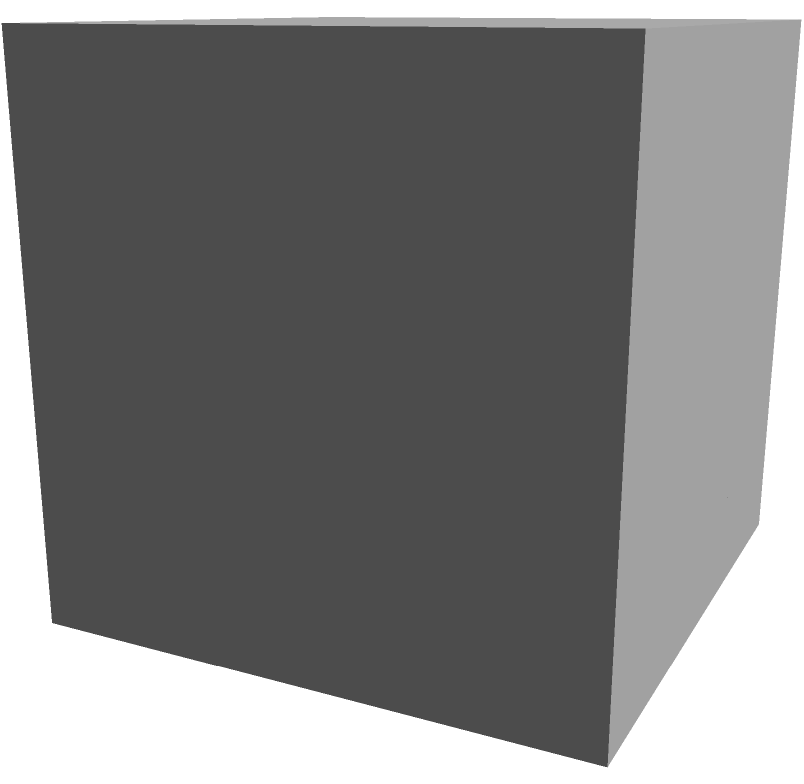In the context of planning educational spaces for early childhood programs, consider a 3D structure composed of smaller cubes. The structure is a 3x3x3 cube, but some smaller cubes are missing. If all cubes on a face touching another cube are present, how many smaller cubes make up this structure? To solve this problem, let's approach it step-by-step:

1) First, visualize a 3x3x3 cube, which would normally contain 27 smaller cubes.

2) The condition "all cubes on a face touching another cube are present" means that only the corner cube where x=0, y=0, z=0 is missing.

3) To verify this, let's check each layer:
   - Bottom layer (z=0): 8 cubes (missing the corner)
   - Middle layer (z=1): 9 cubes
   - Top layer (z=2): 9 cubes

4) To calculate the total:
   $$(8 + 9 + 9) = 26$$

This approach ensures that all cubes touching another cube on any face are included, which is crucial when considering space utilization in educational settings.
Answer: 26 cubes 